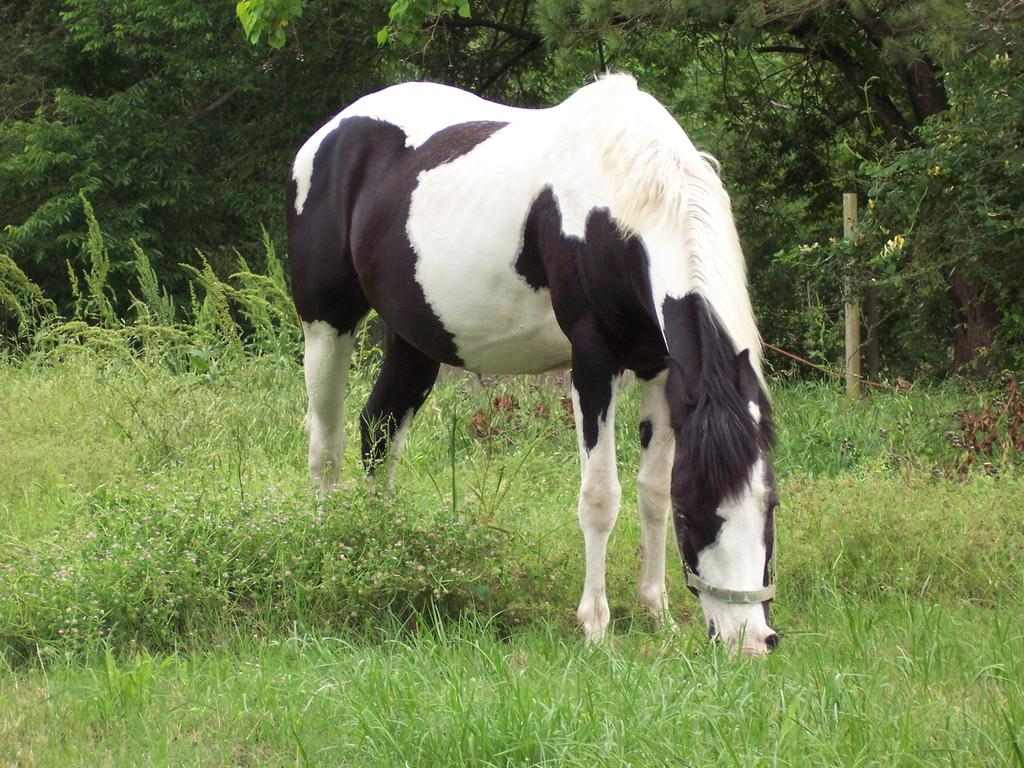What animal is present in the image? There is a horse in the image. What is the horse standing on? The horse is on the surface of the grass. What can be seen in the background of the image? There are trees in the background of the image. What object made of wood can be seen in the image? There is a wooden stick in the image. Can you see any waves in the image? There are no waves present in the image; it features a horse on grass with trees in the background and a wooden stick. 